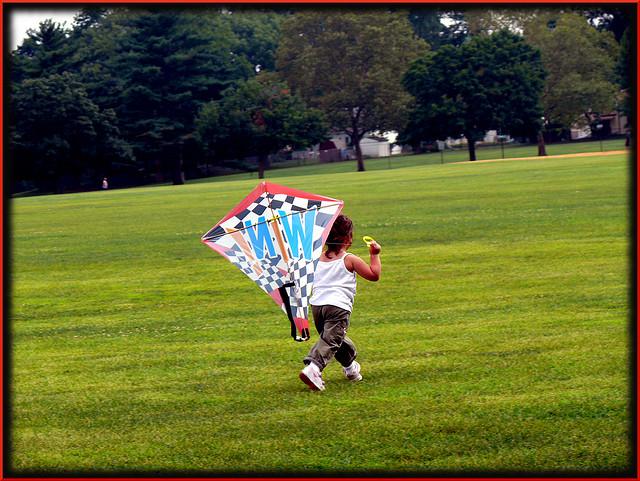What is the kid holding?
Concise answer only. Kite. What material is the kite of?
Quick response, please. Plastic. Are there six or seven tree trunks?
Answer briefly. 6. 